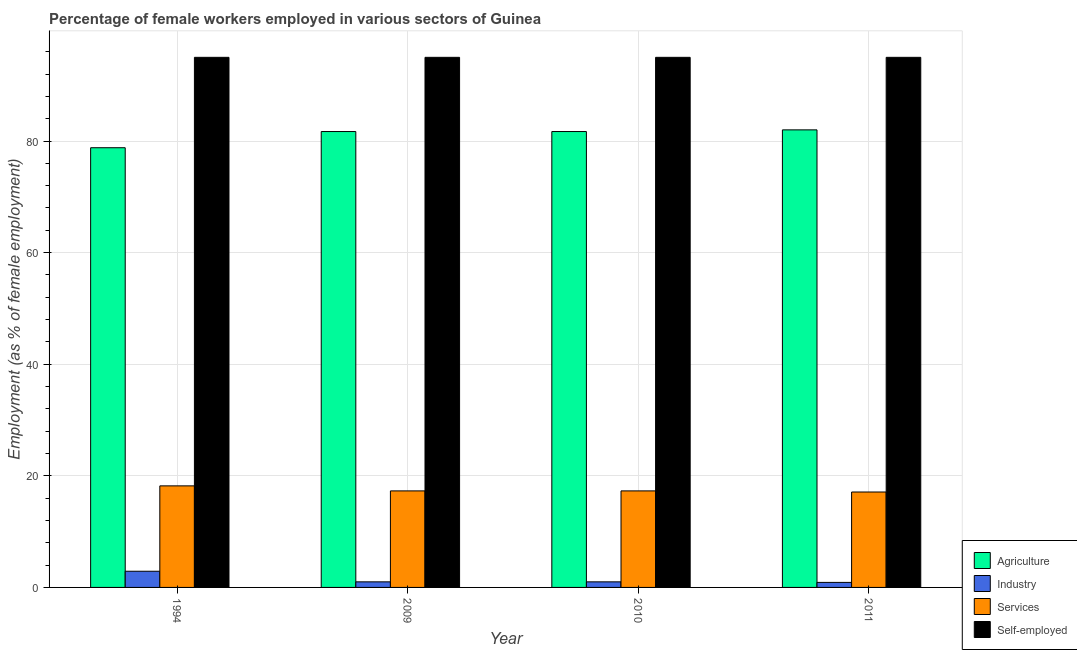How many groups of bars are there?
Your response must be concise. 4. Are the number of bars per tick equal to the number of legend labels?
Ensure brevity in your answer.  Yes. How many bars are there on the 4th tick from the right?
Keep it short and to the point. 4. In how many cases, is the number of bars for a given year not equal to the number of legend labels?
Offer a very short reply. 0. What is the percentage of female workers in services in 2009?
Offer a very short reply. 17.3. Across all years, what is the maximum percentage of female workers in industry?
Give a very brief answer. 2.9. Across all years, what is the minimum percentage of female workers in agriculture?
Your answer should be very brief. 78.8. In which year was the percentage of female workers in agriculture maximum?
Give a very brief answer. 2011. In which year was the percentage of female workers in agriculture minimum?
Offer a terse response. 1994. What is the total percentage of self employed female workers in the graph?
Your response must be concise. 380. What is the difference between the percentage of female workers in services in 1994 and that in 2010?
Give a very brief answer. 0.9. What is the average percentage of female workers in services per year?
Offer a terse response. 17.47. In the year 2011, what is the difference between the percentage of female workers in industry and percentage of self employed female workers?
Offer a terse response. 0. In how many years, is the percentage of self employed female workers greater than 32 %?
Give a very brief answer. 4. Is the percentage of female workers in industry in 2010 less than that in 2011?
Provide a succinct answer. No. Is the difference between the percentage of female workers in industry in 1994 and 2009 greater than the difference between the percentage of female workers in agriculture in 1994 and 2009?
Your answer should be very brief. No. What is the difference between the highest and the second highest percentage of female workers in services?
Offer a very short reply. 0.9. What is the difference between the highest and the lowest percentage of female workers in industry?
Offer a very short reply. 2. In how many years, is the percentage of self employed female workers greater than the average percentage of self employed female workers taken over all years?
Keep it short and to the point. 0. Is the sum of the percentage of female workers in industry in 2010 and 2011 greater than the maximum percentage of female workers in agriculture across all years?
Offer a terse response. No. Is it the case that in every year, the sum of the percentage of female workers in agriculture and percentage of self employed female workers is greater than the sum of percentage of female workers in services and percentage of female workers in industry?
Ensure brevity in your answer.  Yes. What does the 1st bar from the left in 1994 represents?
Your response must be concise. Agriculture. What does the 4th bar from the right in 2010 represents?
Give a very brief answer. Agriculture. How many bars are there?
Your response must be concise. 16. What is the difference between two consecutive major ticks on the Y-axis?
Provide a succinct answer. 20. Does the graph contain grids?
Offer a very short reply. Yes. Where does the legend appear in the graph?
Your response must be concise. Bottom right. What is the title of the graph?
Offer a very short reply. Percentage of female workers employed in various sectors of Guinea. Does "UNDP" appear as one of the legend labels in the graph?
Make the answer very short. No. What is the label or title of the Y-axis?
Your answer should be compact. Employment (as % of female employment). What is the Employment (as % of female employment) of Agriculture in 1994?
Your answer should be compact. 78.8. What is the Employment (as % of female employment) in Industry in 1994?
Keep it short and to the point. 2.9. What is the Employment (as % of female employment) of Services in 1994?
Ensure brevity in your answer.  18.2. What is the Employment (as % of female employment) of Self-employed in 1994?
Ensure brevity in your answer.  95. What is the Employment (as % of female employment) of Agriculture in 2009?
Your answer should be very brief. 81.7. What is the Employment (as % of female employment) in Services in 2009?
Your answer should be compact. 17.3. What is the Employment (as % of female employment) of Self-employed in 2009?
Give a very brief answer. 95. What is the Employment (as % of female employment) of Agriculture in 2010?
Give a very brief answer. 81.7. What is the Employment (as % of female employment) in Industry in 2010?
Keep it short and to the point. 1. What is the Employment (as % of female employment) of Services in 2010?
Offer a very short reply. 17.3. What is the Employment (as % of female employment) of Industry in 2011?
Provide a succinct answer. 0.9. What is the Employment (as % of female employment) in Services in 2011?
Provide a short and direct response. 17.1. Across all years, what is the maximum Employment (as % of female employment) in Industry?
Make the answer very short. 2.9. Across all years, what is the maximum Employment (as % of female employment) of Services?
Your response must be concise. 18.2. Across all years, what is the minimum Employment (as % of female employment) in Agriculture?
Offer a very short reply. 78.8. Across all years, what is the minimum Employment (as % of female employment) of Industry?
Give a very brief answer. 0.9. Across all years, what is the minimum Employment (as % of female employment) of Services?
Give a very brief answer. 17.1. Across all years, what is the minimum Employment (as % of female employment) in Self-employed?
Your answer should be compact. 95. What is the total Employment (as % of female employment) of Agriculture in the graph?
Offer a very short reply. 324.2. What is the total Employment (as % of female employment) of Industry in the graph?
Your answer should be very brief. 5.8. What is the total Employment (as % of female employment) of Services in the graph?
Keep it short and to the point. 69.9. What is the total Employment (as % of female employment) in Self-employed in the graph?
Keep it short and to the point. 380. What is the difference between the Employment (as % of female employment) of Agriculture in 1994 and that in 2009?
Your answer should be compact. -2.9. What is the difference between the Employment (as % of female employment) in Services in 1994 and that in 2009?
Your answer should be very brief. 0.9. What is the difference between the Employment (as % of female employment) in Self-employed in 1994 and that in 2009?
Provide a succinct answer. 0. What is the difference between the Employment (as % of female employment) of Industry in 1994 and that in 2010?
Give a very brief answer. 1.9. What is the difference between the Employment (as % of female employment) in Self-employed in 1994 and that in 2010?
Your answer should be compact. 0. What is the difference between the Employment (as % of female employment) in Industry in 1994 and that in 2011?
Give a very brief answer. 2. What is the difference between the Employment (as % of female employment) in Services in 1994 and that in 2011?
Keep it short and to the point. 1.1. What is the difference between the Employment (as % of female employment) in Self-employed in 1994 and that in 2011?
Your answer should be very brief. 0. What is the difference between the Employment (as % of female employment) in Industry in 2009 and that in 2010?
Ensure brevity in your answer.  0. What is the difference between the Employment (as % of female employment) in Self-employed in 2009 and that in 2010?
Your answer should be compact. 0. What is the difference between the Employment (as % of female employment) of Services in 2009 and that in 2011?
Offer a terse response. 0.2. What is the difference between the Employment (as % of female employment) of Self-employed in 2009 and that in 2011?
Keep it short and to the point. 0. What is the difference between the Employment (as % of female employment) of Agriculture in 2010 and that in 2011?
Your response must be concise. -0.3. What is the difference between the Employment (as % of female employment) of Agriculture in 1994 and the Employment (as % of female employment) of Industry in 2009?
Provide a short and direct response. 77.8. What is the difference between the Employment (as % of female employment) of Agriculture in 1994 and the Employment (as % of female employment) of Services in 2009?
Offer a very short reply. 61.5. What is the difference between the Employment (as % of female employment) of Agriculture in 1994 and the Employment (as % of female employment) of Self-employed in 2009?
Your answer should be compact. -16.2. What is the difference between the Employment (as % of female employment) in Industry in 1994 and the Employment (as % of female employment) in Services in 2009?
Give a very brief answer. -14.4. What is the difference between the Employment (as % of female employment) of Industry in 1994 and the Employment (as % of female employment) of Self-employed in 2009?
Keep it short and to the point. -92.1. What is the difference between the Employment (as % of female employment) in Services in 1994 and the Employment (as % of female employment) in Self-employed in 2009?
Keep it short and to the point. -76.8. What is the difference between the Employment (as % of female employment) of Agriculture in 1994 and the Employment (as % of female employment) of Industry in 2010?
Ensure brevity in your answer.  77.8. What is the difference between the Employment (as % of female employment) of Agriculture in 1994 and the Employment (as % of female employment) of Services in 2010?
Your answer should be very brief. 61.5. What is the difference between the Employment (as % of female employment) in Agriculture in 1994 and the Employment (as % of female employment) in Self-employed in 2010?
Your response must be concise. -16.2. What is the difference between the Employment (as % of female employment) in Industry in 1994 and the Employment (as % of female employment) in Services in 2010?
Keep it short and to the point. -14.4. What is the difference between the Employment (as % of female employment) in Industry in 1994 and the Employment (as % of female employment) in Self-employed in 2010?
Give a very brief answer. -92.1. What is the difference between the Employment (as % of female employment) in Services in 1994 and the Employment (as % of female employment) in Self-employed in 2010?
Ensure brevity in your answer.  -76.8. What is the difference between the Employment (as % of female employment) of Agriculture in 1994 and the Employment (as % of female employment) of Industry in 2011?
Provide a short and direct response. 77.9. What is the difference between the Employment (as % of female employment) in Agriculture in 1994 and the Employment (as % of female employment) in Services in 2011?
Provide a succinct answer. 61.7. What is the difference between the Employment (as % of female employment) of Agriculture in 1994 and the Employment (as % of female employment) of Self-employed in 2011?
Keep it short and to the point. -16.2. What is the difference between the Employment (as % of female employment) in Industry in 1994 and the Employment (as % of female employment) in Self-employed in 2011?
Your answer should be compact. -92.1. What is the difference between the Employment (as % of female employment) of Services in 1994 and the Employment (as % of female employment) of Self-employed in 2011?
Offer a terse response. -76.8. What is the difference between the Employment (as % of female employment) of Agriculture in 2009 and the Employment (as % of female employment) of Industry in 2010?
Provide a succinct answer. 80.7. What is the difference between the Employment (as % of female employment) of Agriculture in 2009 and the Employment (as % of female employment) of Services in 2010?
Your response must be concise. 64.4. What is the difference between the Employment (as % of female employment) of Agriculture in 2009 and the Employment (as % of female employment) of Self-employed in 2010?
Your answer should be compact. -13.3. What is the difference between the Employment (as % of female employment) of Industry in 2009 and the Employment (as % of female employment) of Services in 2010?
Your response must be concise. -16.3. What is the difference between the Employment (as % of female employment) of Industry in 2009 and the Employment (as % of female employment) of Self-employed in 2010?
Give a very brief answer. -94. What is the difference between the Employment (as % of female employment) of Services in 2009 and the Employment (as % of female employment) of Self-employed in 2010?
Your answer should be compact. -77.7. What is the difference between the Employment (as % of female employment) in Agriculture in 2009 and the Employment (as % of female employment) in Industry in 2011?
Ensure brevity in your answer.  80.8. What is the difference between the Employment (as % of female employment) in Agriculture in 2009 and the Employment (as % of female employment) in Services in 2011?
Your answer should be very brief. 64.6. What is the difference between the Employment (as % of female employment) of Agriculture in 2009 and the Employment (as % of female employment) of Self-employed in 2011?
Your answer should be very brief. -13.3. What is the difference between the Employment (as % of female employment) in Industry in 2009 and the Employment (as % of female employment) in Services in 2011?
Provide a short and direct response. -16.1. What is the difference between the Employment (as % of female employment) of Industry in 2009 and the Employment (as % of female employment) of Self-employed in 2011?
Give a very brief answer. -94. What is the difference between the Employment (as % of female employment) of Services in 2009 and the Employment (as % of female employment) of Self-employed in 2011?
Your answer should be very brief. -77.7. What is the difference between the Employment (as % of female employment) of Agriculture in 2010 and the Employment (as % of female employment) of Industry in 2011?
Your answer should be very brief. 80.8. What is the difference between the Employment (as % of female employment) in Agriculture in 2010 and the Employment (as % of female employment) in Services in 2011?
Provide a short and direct response. 64.6. What is the difference between the Employment (as % of female employment) of Agriculture in 2010 and the Employment (as % of female employment) of Self-employed in 2011?
Your answer should be compact. -13.3. What is the difference between the Employment (as % of female employment) in Industry in 2010 and the Employment (as % of female employment) in Services in 2011?
Make the answer very short. -16.1. What is the difference between the Employment (as % of female employment) in Industry in 2010 and the Employment (as % of female employment) in Self-employed in 2011?
Your answer should be very brief. -94. What is the difference between the Employment (as % of female employment) of Services in 2010 and the Employment (as % of female employment) of Self-employed in 2011?
Ensure brevity in your answer.  -77.7. What is the average Employment (as % of female employment) of Agriculture per year?
Offer a terse response. 81.05. What is the average Employment (as % of female employment) in Industry per year?
Your response must be concise. 1.45. What is the average Employment (as % of female employment) in Services per year?
Your answer should be compact. 17.48. In the year 1994, what is the difference between the Employment (as % of female employment) of Agriculture and Employment (as % of female employment) of Industry?
Offer a terse response. 75.9. In the year 1994, what is the difference between the Employment (as % of female employment) in Agriculture and Employment (as % of female employment) in Services?
Provide a succinct answer. 60.6. In the year 1994, what is the difference between the Employment (as % of female employment) in Agriculture and Employment (as % of female employment) in Self-employed?
Give a very brief answer. -16.2. In the year 1994, what is the difference between the Employment (as % of female employment) of Industry and Employment (as % of female employment) of Services?
Offer a terse response. -15.3. In the year 1994, what is the difference between the Employment (as % of female employment) in Industry and Employment (as % of female employment) in Self-employed?
Offer a terse response. -92.1. In the year 1994, what is the difference between the Employment (as % of female employment) in Services and Employment (as % of female employment) in Self-employed?
Your answer should be very brief. -76.8. In the year 2009, what is the difference between the Employment (as % of female employment) of Agriculture and Employment (as % of female employment) of Industry?
Your response must be concise. 80.7. In the year 2009, what is the difference between the Employment (as % of female employment) in Agriculture and Employment (as % of female employment) in Services?
Ensure brevity in your answer.  64.4. In the year 2009, what is the difference between the Employment (as % of female employment) of Industry and Employment (as % of female employment) of Services?
Your answer should be compact. -16.3. In the year 2009, what is the difference between the Employment (as % of female employment) in Industry and Employment (as % of female employment) in Self-employed?
Give a very brief answer. -94. In the year 2009, what is the difference between the Employment (as % of female employment) of Services and Employment (as % of female employment) of Self-employed?
Keep it short and to the point. -77.7. In the year 2010, what is the difference between the Employment (as % of female employment) in Agriculture and Employment (as % of female employment) in Industry?
Your answer should be very brief. 80.7. In the year 2010, what is the difference between the Employment (as % of female employment) of Agriculture and Employment (as % of female employment) of Services?
Make the answer very short. 64.4. In the year 2010, what is the difference between the Employment (as % of female employment) in Agriculture and Employment (as % of female employment) in Self-employed?
Ensure brevity in your answer.  -13.3. In the year 2010, what is the difference between the Employment (as % of female employment) of Industry and Employment (as % of female employment) of Services?
Make the answer very short. -16.3. In the year 2010, what is the difference between the Employment (as % of female employment) of Industry and Employment (as % of female employment) of Self-employed?
Provide a short and direct response. -94. In the year 2010, what is the difference between the Employment (as % of female employment) of Services and Employment (as % of female employment) of Self-employed?
Make the answer very short. -77.7. In the year 2011, what is the difference between the Employment (as % of female employment) of Agriculture and Employment (as % of female employment) of Industry?
Keep it short and to the point. 81.1. In the year 2011, what is the difference between the Employment (as % of female employment) of Agriculture and Employment (as % of female employment) of Services?
Ensure brevity in your answer.  64.9. In the year 2011, what is the difference between the Employment (as % of female employment) of Agriculture and Employment (as % of female employment) of Self-employed?
Give a very brief answer. -13. In the year 2011, what is the difference between the Employment (as % of female employment) of Industry and Employment (as % of female employment) of Services?
Provide a succinct answer. -16.2. In the year 2011, what is the difference between the Employment (as % of female employment) in Industry and Employment (as % of female employment) in Self-employed?
Make the answer very short. -94.1. In the year 2011, what is the difference between the Employment (as % of female employment) of Services and Employment (as % of female employment) of Self-employed?
Keep it short and to the point. -77.9. What is the ratio of the Employment (as % of female employment) of Agriculture in 1994 to that in 2009?
Your answer should be compact. 0.96. What is the ratio of the Employment (as % of female employment) of Industry in 1994 to that in 2009?
Offer a terse response. 2.9. What is the ratio of the Employment (as % of female employment) of Services in 1994 to that in 2009?
Your response must be concise. 1.05. What is the ratio of the Employment (as % of female employment) of Agriculture in 1994 to that in 2010?
Your answer should be compact. 0.96. What is the ratio of the Employment (as % of female employment) of Industry in 1994 to that in 2010?
Your answer should be very brief. 2.9. What is the ratio of the Employment (as % of female employment) of Services in 1994 to that in 2010?
Ensure brevity in your answer.  1.05. What is the ratio of the Employment (as % of female employment) of Industry in 1994 to that in 2011?
Your response must be concise. 3.22. What is the ratio of the Employment (as % of female employment) in Services in 1994 to that in 2011?
Give a very brief answer. 1.06. What is the ratio of the Employment (as % of female employment) of Agriculture in 2009 to that in 2010?
Your answer should be very brief. 1. What is the ratio of the Employment (as % of female employment) in Industry in 2009 to that in 2010?
Give a very brief answer. 1. What is the ratio of the Employment (as % of female employment) in Self-employed in 2009 to that in 2010?
Provide a succinct answer. 1. What is the ratio of the Employment (as % of female employment) of Agriculture in 2009 to that in 2011?
Your response must be concise. 1. What is the ratio of the Employment (as % of female employment) in Industry in 2009 to that in 2011?
Provide a succinct answer. 1.11. What is the ratio of the Employment (as % of female employment) of Services in 2009 to that in 2011?
Keep it short and to the point. 1.01. What is the ratio of the Employment (as % of female employment) of Self-employed in 2009 to that in 2011?
Your response must be concise. 1. What is the ratio of the Employment (as % of female employment) of Industry in 2010 to that in 2011?
Offer a terse response. 1.11. What is the ratio of the Employment (as % of female employment) in Services in 2010 to that in 2011?
Offer a very short reply. 1.01. What is the ratio of the Employment (as % of female employment) of Self-employed in 2010 to that in 2011?
Provide a succinct answer. 1. What is the difference between the highest and the second highest Employment (as % of female employment) of Industry?
Offer a very short reply. 1.9. What is the difference between the highest and the second highest Employment (as % of female employment) in Services?
Provide a short and direct response. 0.9. What is the difference between the highest and the lowest Employment (as % of female employment) in Agriculture?
Give a very brief answer. 3.2. What is the difference between the highest and the lowest Employment (as % of female employment) of Self-employed?
Ensure brevity in your answer.  0. 